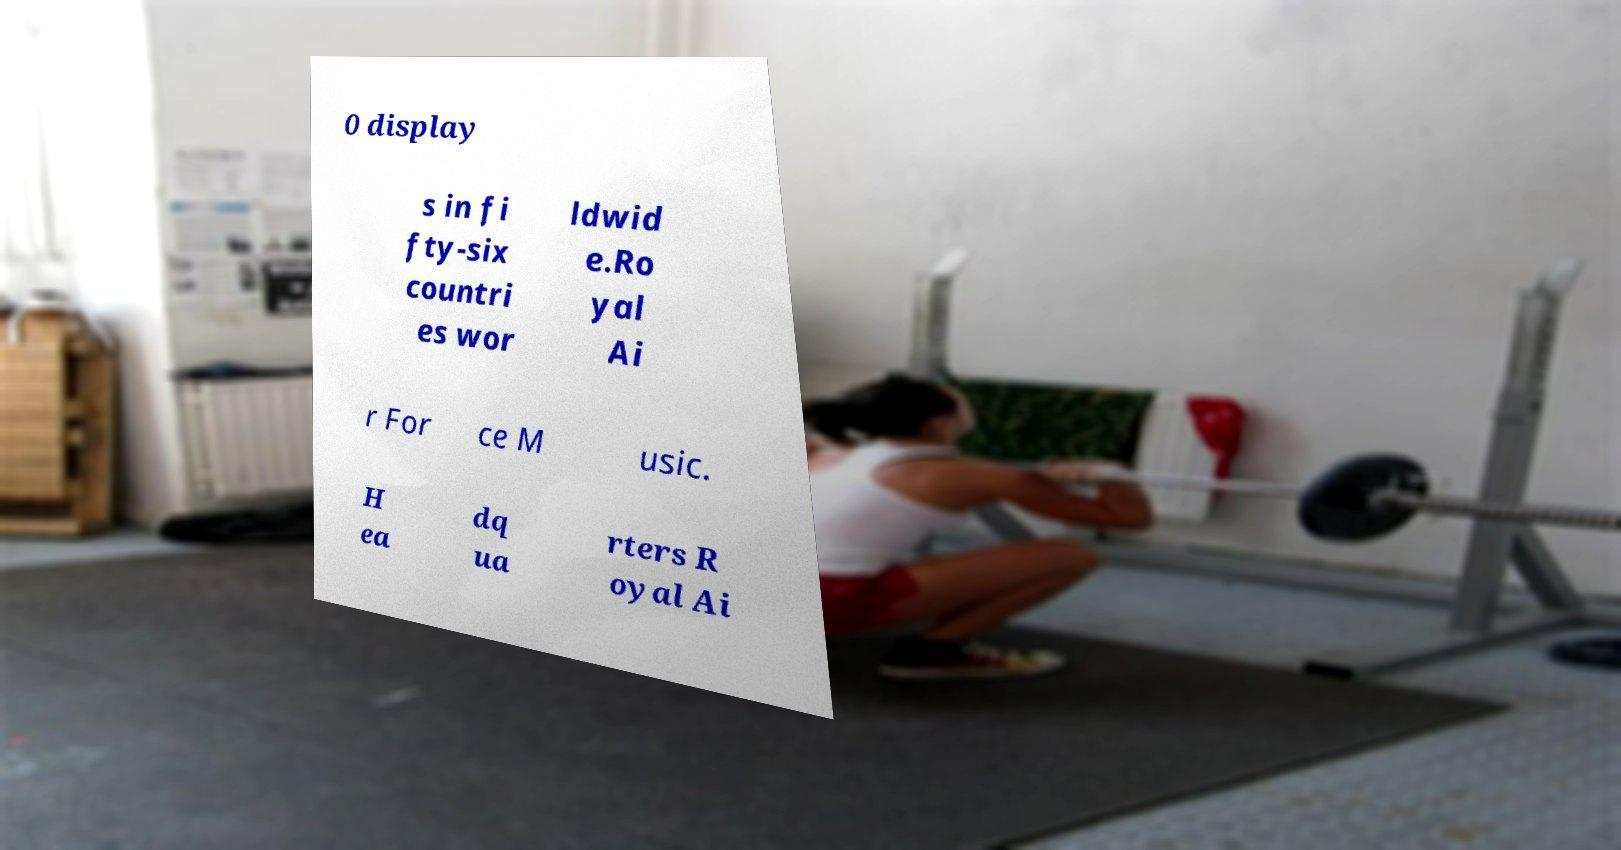I need the written content from this picture converted into text. Can you do that? 0 display s in fi fty-six countri es wor ldwid e.Ro yal Ai r For ce M usic. H ea dq ua rters R oyal Ai 